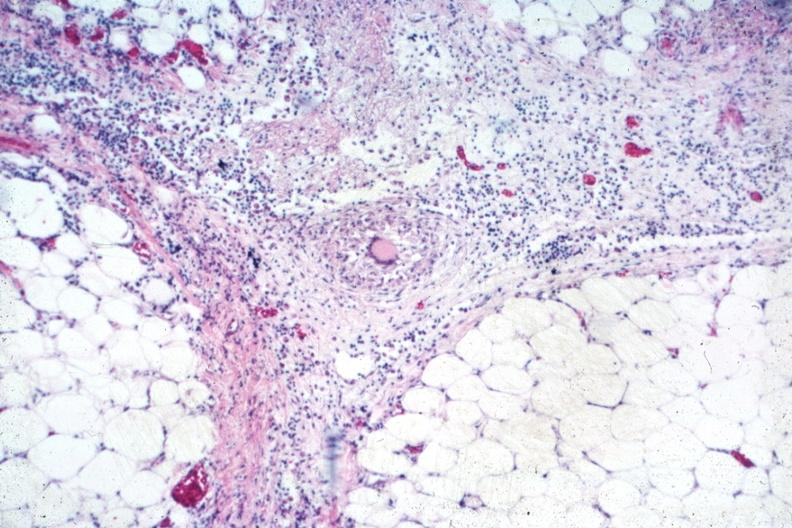s abdomen present?
Answer the question using a single word or phrase. Yes 